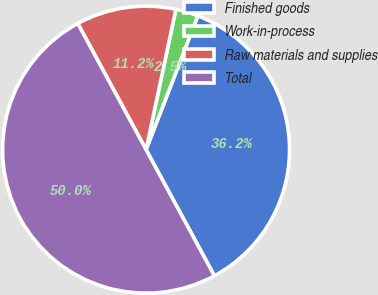Convert chart to OTSL. <chart><loc_0><loc_0><loc_500><loc_500><pie_chart><fcel>Finished goods<fcel>Work-in-process<fcel>Raw materials and supplies<fcel>Total<nl><fcel>36.23%<fcel>2.54%<fcel>11.23%<fcel>50.0%<nl></chart> 